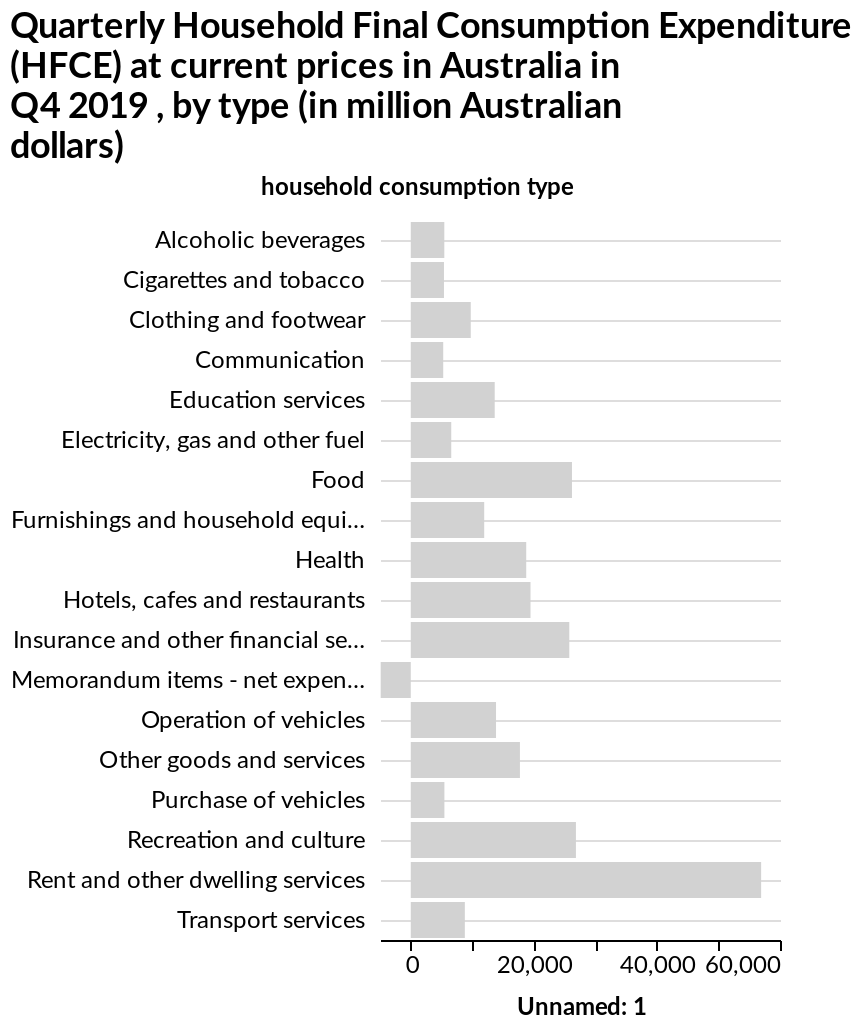<image>
What is the overall trend in quarterly expenditure? The overall trend in quarterly expenditure is growth, except for a slight decrease in memorandum items net expenditure. 